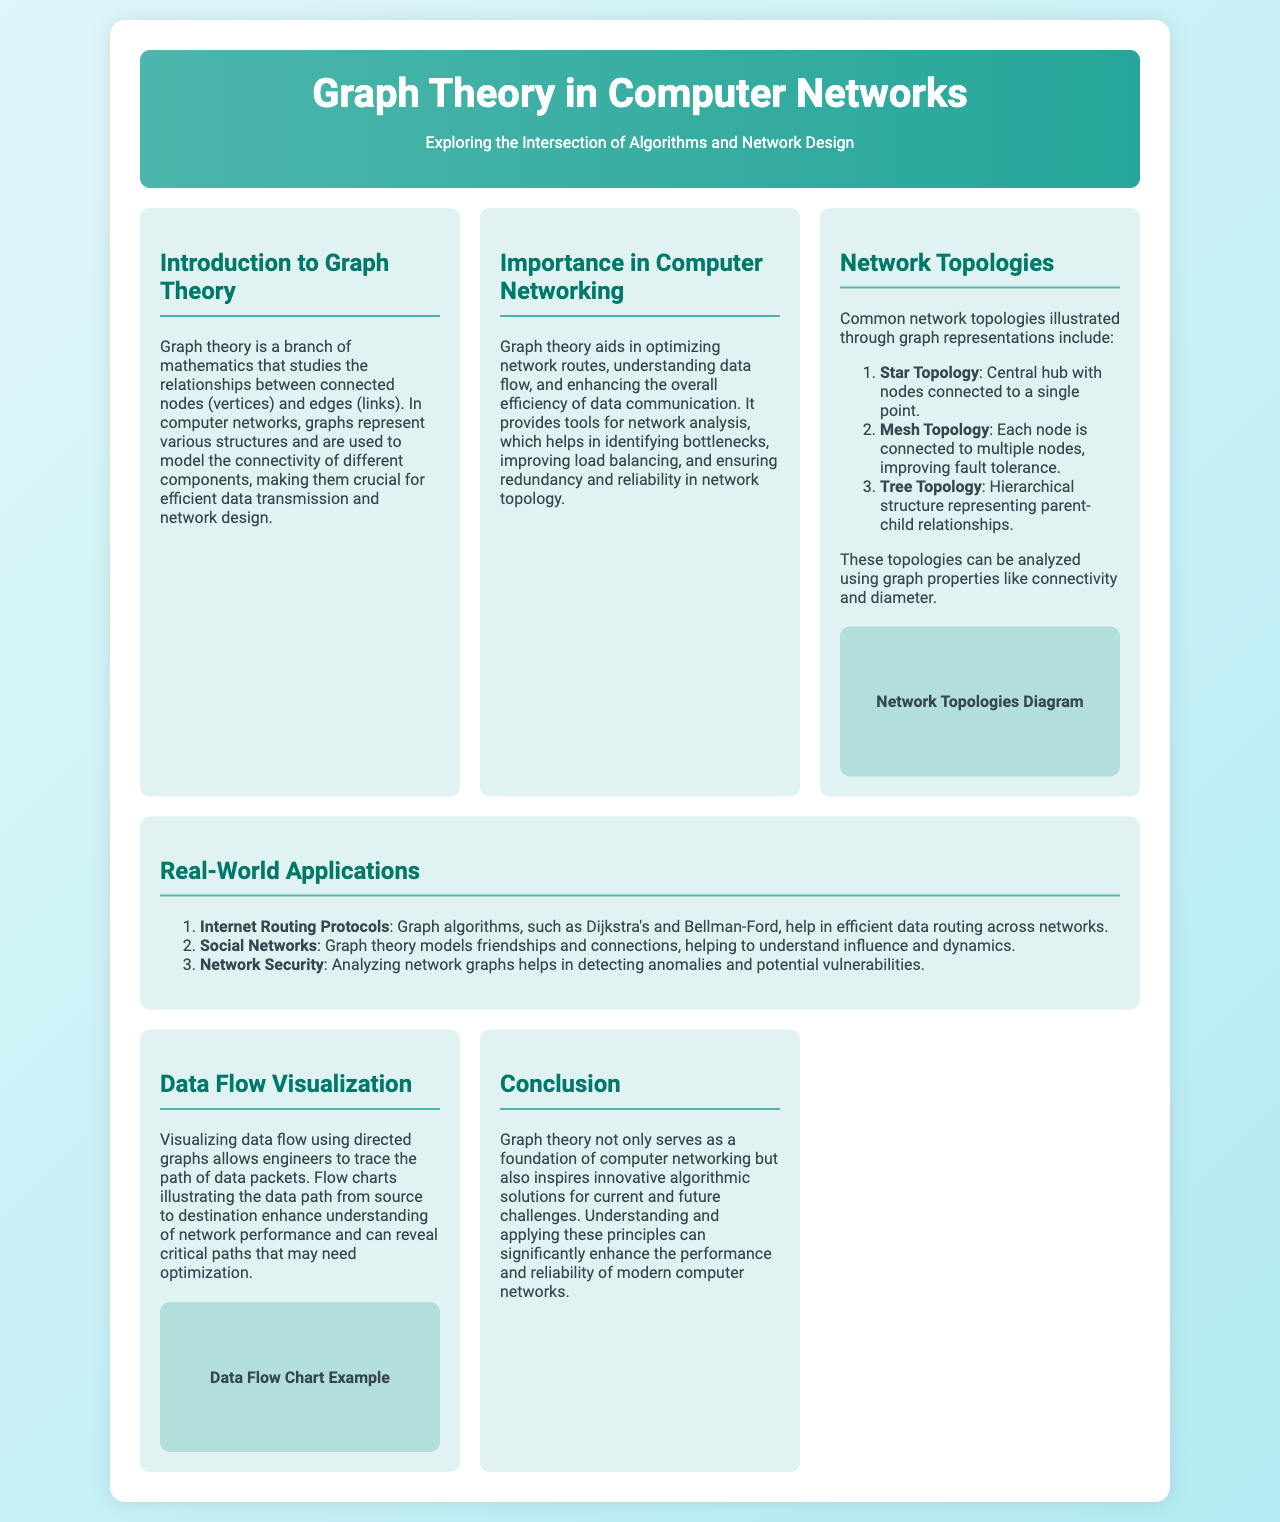What is the main topic of the brochure? The main topic is mentioned in the title and the header, signifying that it focuses on graph theory's role in networking.
Answer: Graph Theory in Computer Networks What are the three common network topologies mentioned? The document lists three specific topologies in the corresponding section.
Answer: Star Topology, Mesh Topology, Tree Topology Who helps in efficient data routing according to the real-world applications section? The real-world applications section specifies the protocols involved in data routing using graph algorithms.
Answer: Internet Routing Protocols What graph algorithms are mentioned for data routing? The document explicitly mentions two graph algorithms used for routing efficiency.
Answer: Dijkstra's and Bellman-Ford What does data flow visualization enhance? The document states the purpose and benefit of visualizing data flow in networking contexts.
Answer: Understanding of network performance What does graph theory inspire according to the conclusion? The conclusion discusses the broader impact and inspiration drawn from graph theory within the context of algorithms.
Answer: Innovative algorithmic solutions What color scheme is used for the background gradient of the brochure? The code specifies the colors used for the background gradient effect in the style section.
Answer: #e0f7fa, #b2ebf2 How many sections are there in the brochure? By counting the individual sections presented in the document, we can determine the total number.
Answer: Six sections 